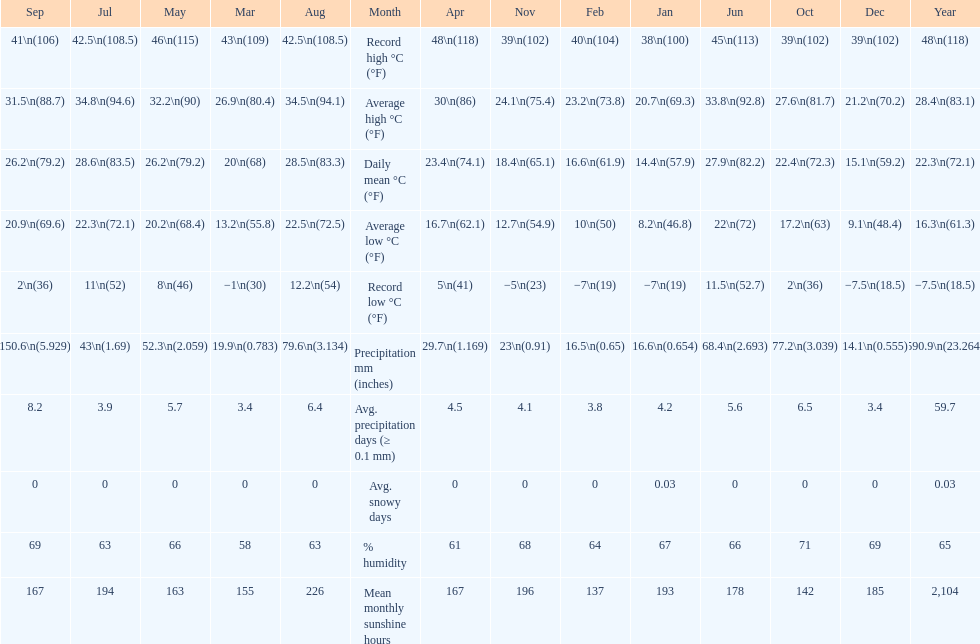Which month had the most sunny days? August. 